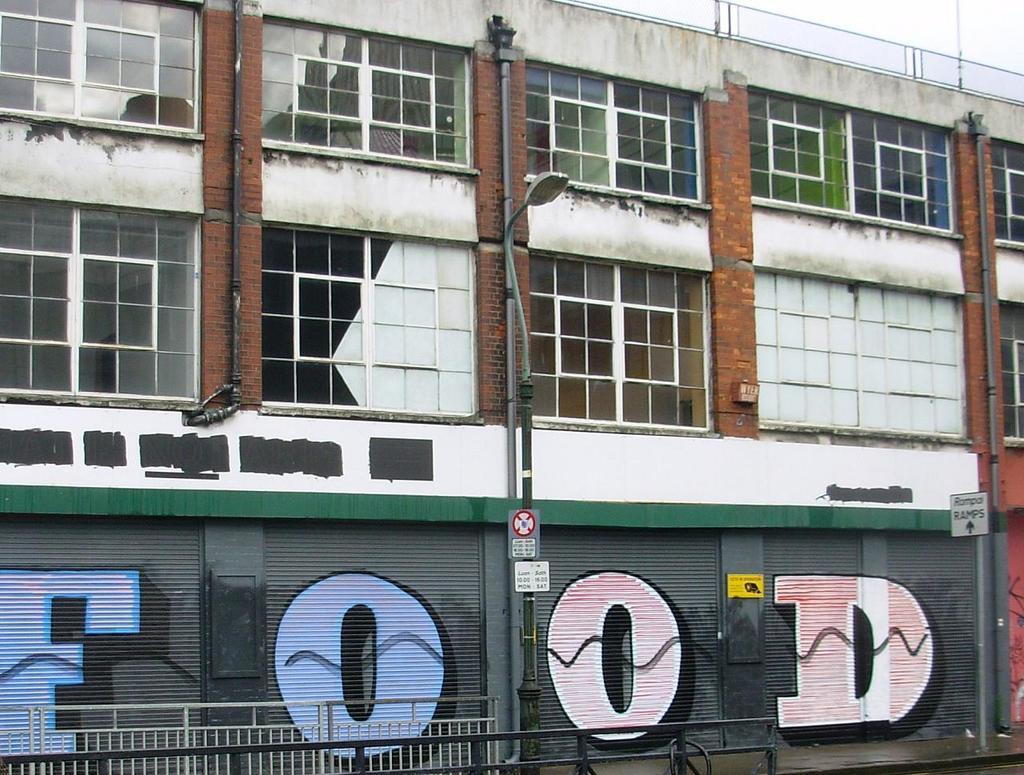Can you describe this image briefly? In this image I can see a pole in the front and on it I can see few boards and a street light. On these words I can see something is written. In the background I can see a building and on the right side of this image I can see few more boards. I can also see something is written on these boards. 